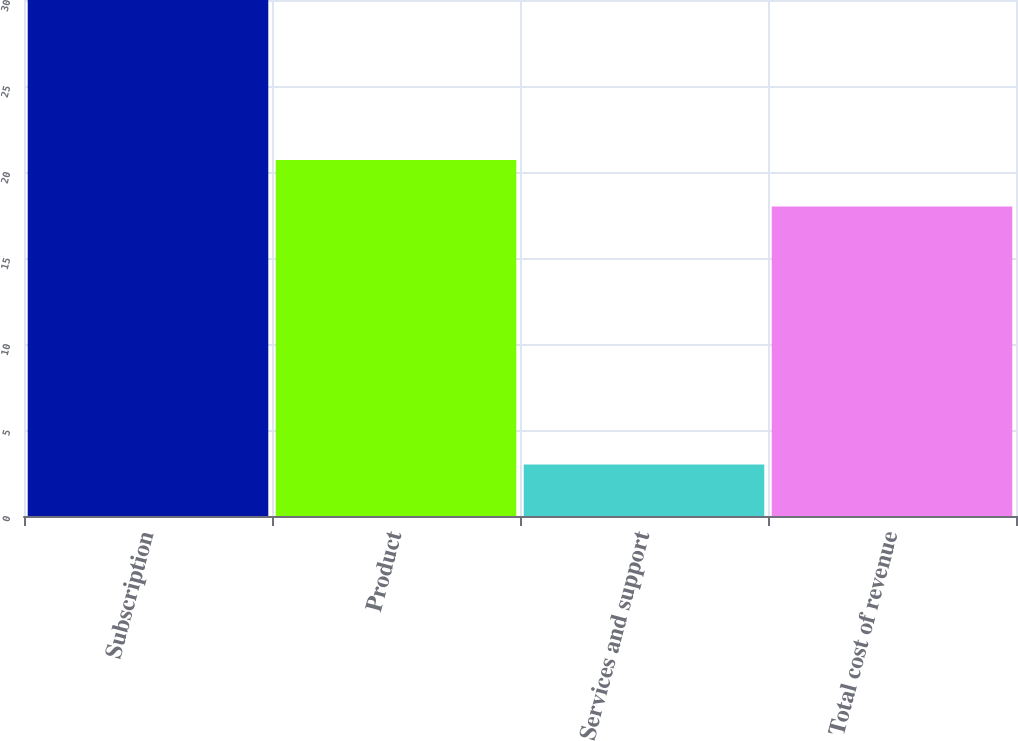Convert chart to OTSL. <chart><loc_0><loc_0><loc_500><loc_500><bar_chart><fcel>Subscription<fcel>Product<fcel>Services and support<fcel>Total cost of revenue<nl><fcel>30<fcel>20.7<fcel>3<fcel>18<nl></chart> 